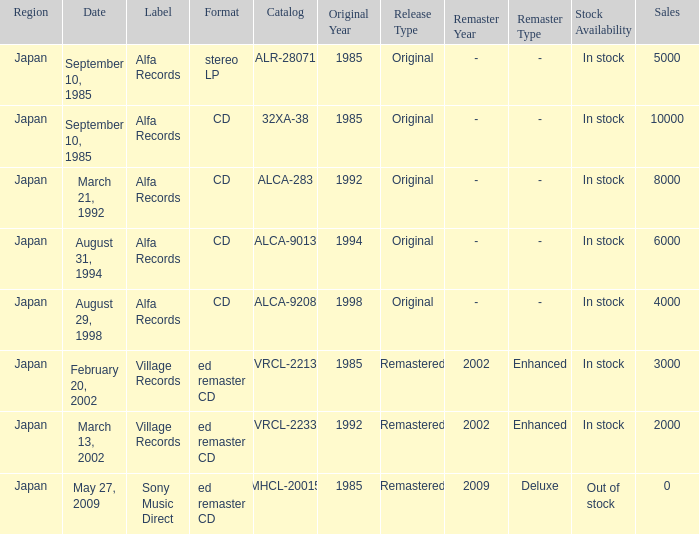Which Catalog was formated as a CD under the label Alfa Records? 32XA-38, ALCA-283, ALCA-9013, ALCA-9208. 